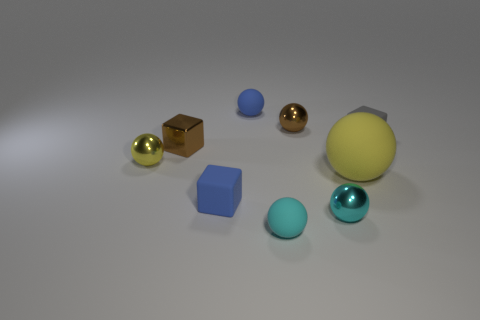Is there a metallic thing of the same color as the big rubber thing?
Offer a terse response. Yes. The metallic block that is the same size as the yellow metal thing is what color?
Keep it short and to the point. Brown. What is the tiny blue object behind the yellow thing that is to the left of the small brown thing that is to the right of the cyan matte object made of?
Give a very brief answer. Rubber. There is a shiny block; is its color the same as the large rubber ball that is in front of the small gray rubber cube?
Give a very brief answer. No. What number of objects are either yellow things on the left side of the big yellow rubber ball or shiny spheres left of the brown sphere?
Provide a short and direct response. 1. There is a cyan thing that is behind the tiny cyan matte ball in front of the tiny blue cube; what is its shape?
Make the answer very short. Sphere. Is there a cyan cylinder that has the same material as the small blue block?
Offer a terse response. No. The tiny metal object that is the same shape as the tiny gray matte object is what color?
Your answer should be very brief. Brown. Is the number of big objects on the right side of the gray matte block less than the number of matte things that are in front of the shiny cube?
Provide a succinct answer. Yes. What number of other objects are there of the same shape as the gray object?
Your response must be concise. 2. 